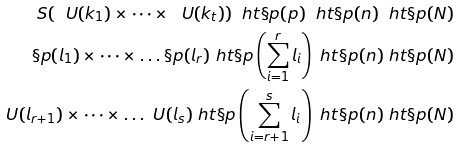Convert formula to latex. <formula><loc_0><loc_0><loc_500><loc_500>S ( \ U ( k _ { 1 } ) \times \dots \times \ U ( k _ { t } ) ) \ h t \S p ( p ) \ h t \S p ( n ) \ h t \S p ( N ) \\ \S p ( l _ { 1 } ) \times \dots \times \dots \S p ( l _ { r } ) \ h t \S p \left ( \sum _ { i = 1 } ^ { r } l _ { i } \right ) \ h t \S p ( n ) \ h t \S p ( N ) \\ \ U ( l _ { r + 1 } ) \times \dots \times \dots \ U ( l _ { s } ) \ h t \S p \left ( \sum _ { i = r + 1 } ^ { s } l _ { i } \right ) \ h t \S p ( n ) \ h t \S p ( N ) \\</formula> 